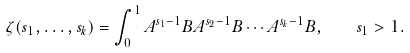<formula> <loc_0><loc_0><loc_500><loc_500>\zeta ( s _ { 1 } , \dots , s _ { k } ) = \int _ { 0 } ^ { 1 } A ^ { s _ { 1 } - 1 } B A ^ { s _ { 2 } - 1 } B \cdots A ^ { s _ { k } - 1 } B , \quad s _ { 1 } > 1 .</formula> 